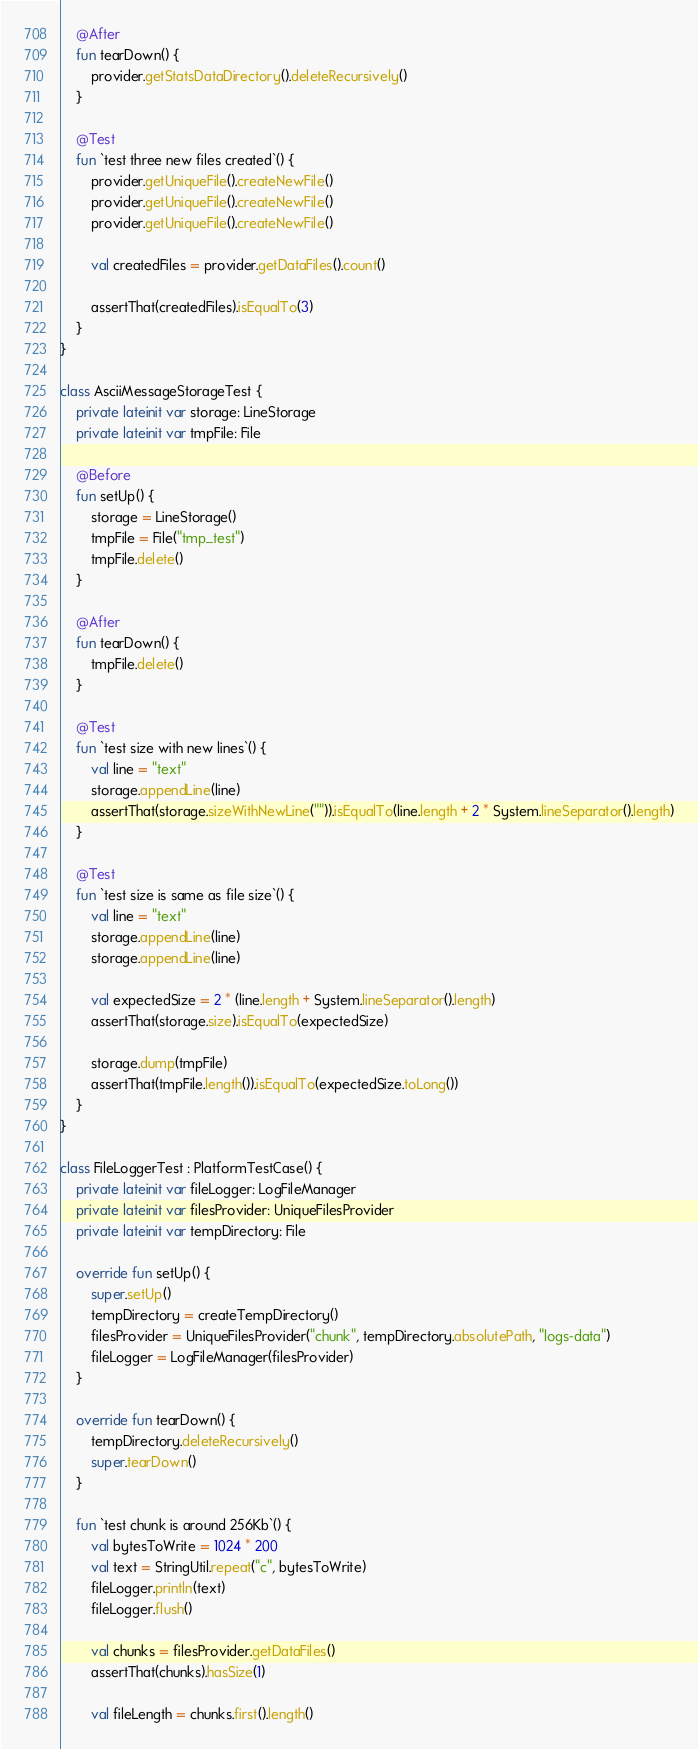<code> <loc_0><loc_0><loc_500><loc_500><_Kotlin_>    @After
    fun tearDown() {
        provider.getStatsDataDirectory().deleteRecursively()
    }
    
    @Test
    fun `test three new files created`() {
        provider.getUniqueFile().createNewFile()
        provider.getUniqueFile().createNewFile()
        provider.getUniqueFile().createNewFile()
        
        val createdFiles = provider.getDataFiles().count()
        
        assertThat(createdFiles).isEqualTo(3)
    }
}

class AsciiMessageStorageTest {
    private lateinit var storage: LineStorage
    private lateinit var tmpFile: File

    @Before
    fun setUp() {
        storage = LineStorage()
        tmpFile = File("tmp_test")
        tmpFile.delete()
    }

    @After
    fun tearDown() {
        tmpFile.delete()
    }

    @Test
    fun `test size with new lines`() {
        val line = "text"
        storage.appendLine(line)
        assertThat(storage.sizeWithNewLine("")).isEqualTo(line.length + 2 * System.lineSeparator().length)
    }
    
    @Test
    fun `test size is same as file size`() {
        val line = "text"
        storage.appendLine(line)
        storage.appendLine(line)

        val expectedSize = 2 * (line.length + System.lineSeparator().length)
        assertThat(storage.size).isEqualTo(expectedSize)

        storage.dump(tmpFile)
        assertThat(tmpFile.length()).isEqualTo(expectedSize.toLong())
    }
}

class FileLoggerTest : PlatformTestCase() {
    private lateinit var fileLogger: LogFileManager
    private lateinit var filesProvider: UniqueFilesProvider
    private lateinit var tempDirectory: File

    override fun setUp() {
        super.setUp()
        tempDirectory = createTempDirectory()
        filesProvider = UniqueFilesProvider("chunk", tempDirectory.absolutePath, "logs-data")
        fileLogger = LogFileManager(filesProvider)
    }

    override fun tearDown() {
        tempDirectory.deleteRecursively()
        super.tearDown()
    }

    fun `test chunk is around 256Kb`() {
        val bytesToWrite = 1024 * 200
        val text = StringUtil.repeat("c", bytesToWrite)
        fileLogger.println(text)
        fileLogger.flush()

        val chunks = filesProvider.getDataFiles()
        assertThat(chunks).hasSize(1)

        val fileLength = chunks.first().length()</code> 